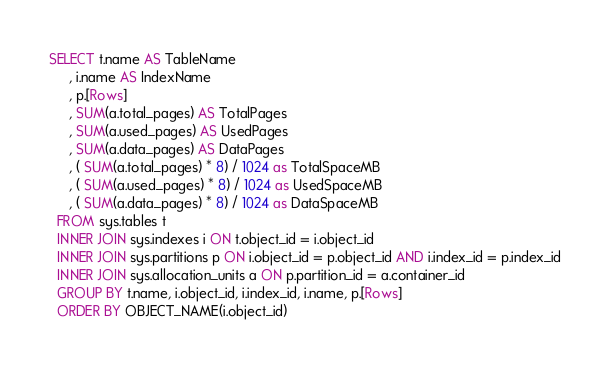Convert code to text. <code><loc_0><loc_0><loc_500><loc_500><_SQL_>SELECT t.name AS TableName
     , i.name AS IndexName
	 , p.[Rows]
	 , SUM(a.total_pages) AS TotalPages
	 , SUM(a.used_pages) AS UsedPages
	 , SUM(a.data_pages) AS DataPages
	 , ( SUM(a.total_pages) * 8) / 1024 as TotalSpaceMB
	 , ( SUM(a.used_pages) * 8) / 1024 as UsedSpaceMB
	 , ( SUM(a.data_pages) * 8) / 1024 as DataSpaceMB
  FROM sys.tables t
  INNER JOIN sys.indexes i ON t.object_id = i.object_id
  INNER JOIN sys.partitions p ON i.object_id = p.object_id AND i.index_id = p.index_id
  INNER JOIN sys.allocation_units a ON p.partition_id = a.container_id
  GROUP BY t.name, i.object_id, i.index_id, i.name, p.[Rows]
  ORDER BY OBJECT_NAME(i.object_id)
</code> 